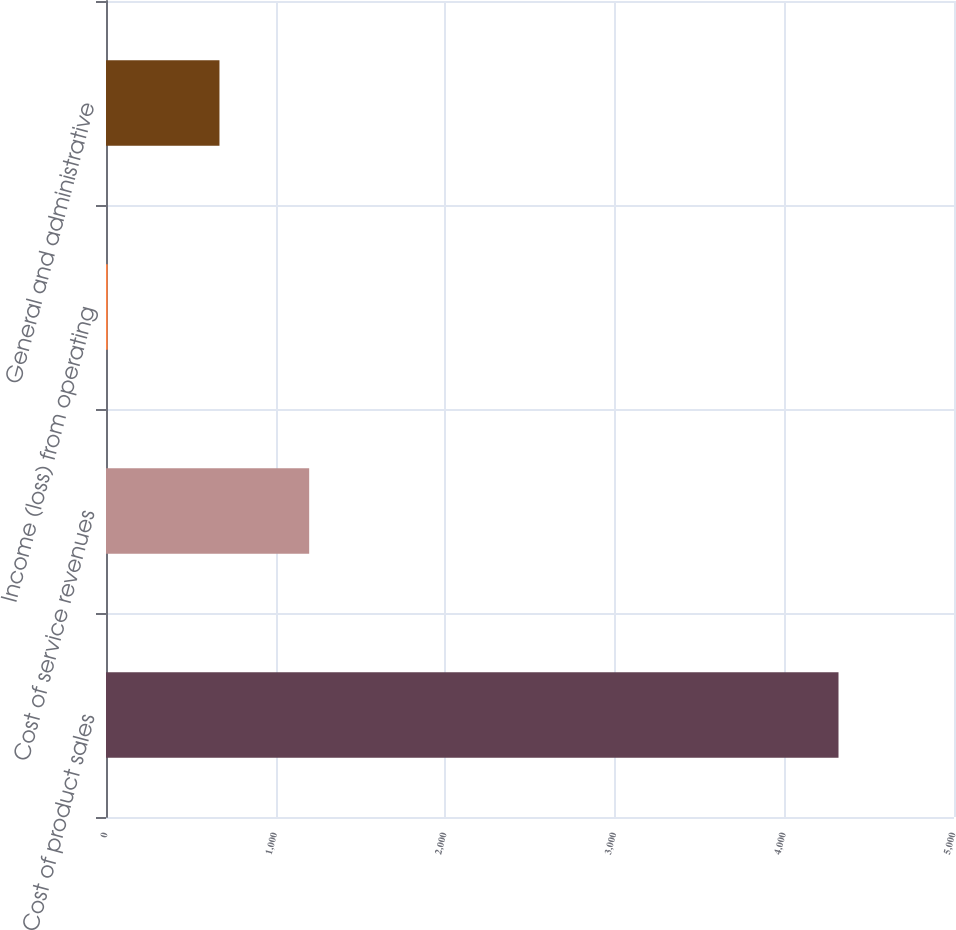<chart> <loc_0><loc_0><loc_500><loc_500><bar_chart><fcel>Cost of product sales<fcel>Cost of service revenues<fcel>Income (loss) from operating<fcel>General and administrative<nl><fcel>4319<fcel>1198<fcel>10<fcel>669<nl></chart> 